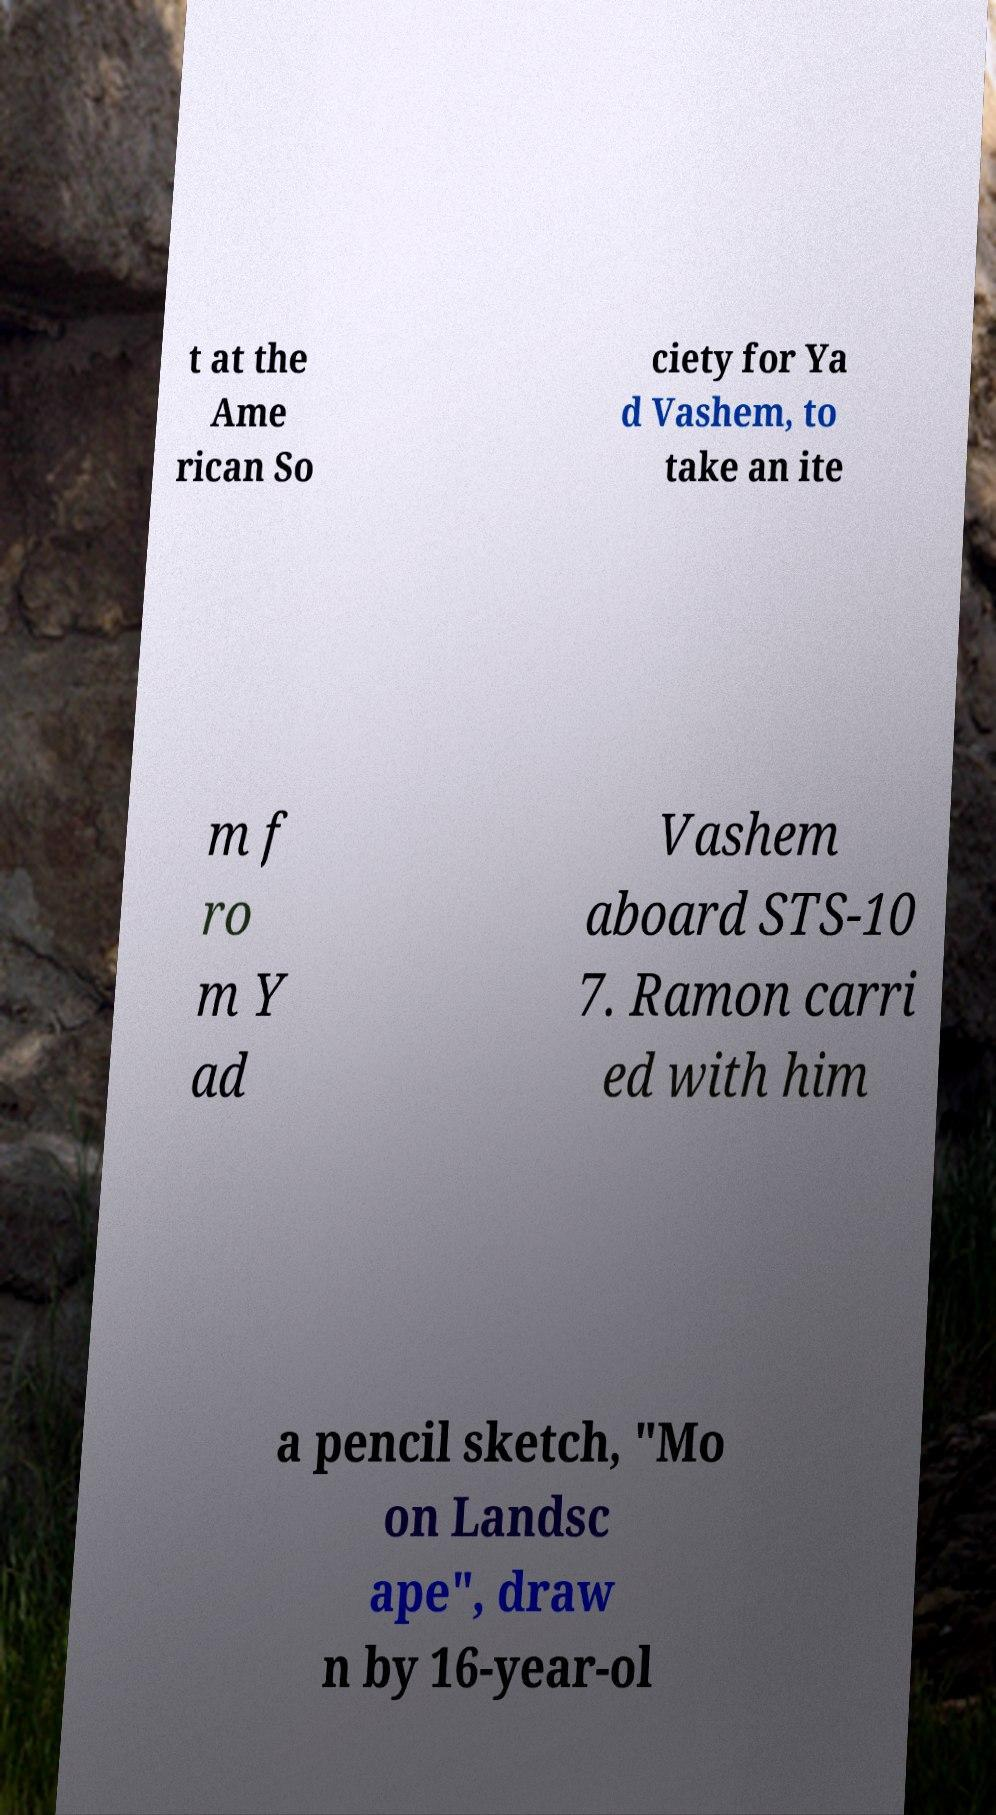Please identify and transcribe the text found in this image. t at the Ame rican So ciety for Ya d Vashem, to take an ite m f ro m Y ad Vashem aboard STS-10 7. Ramon carri ed with him a pencil sketch, "Mo on Landsc ape", draw n by 16-year-ol 